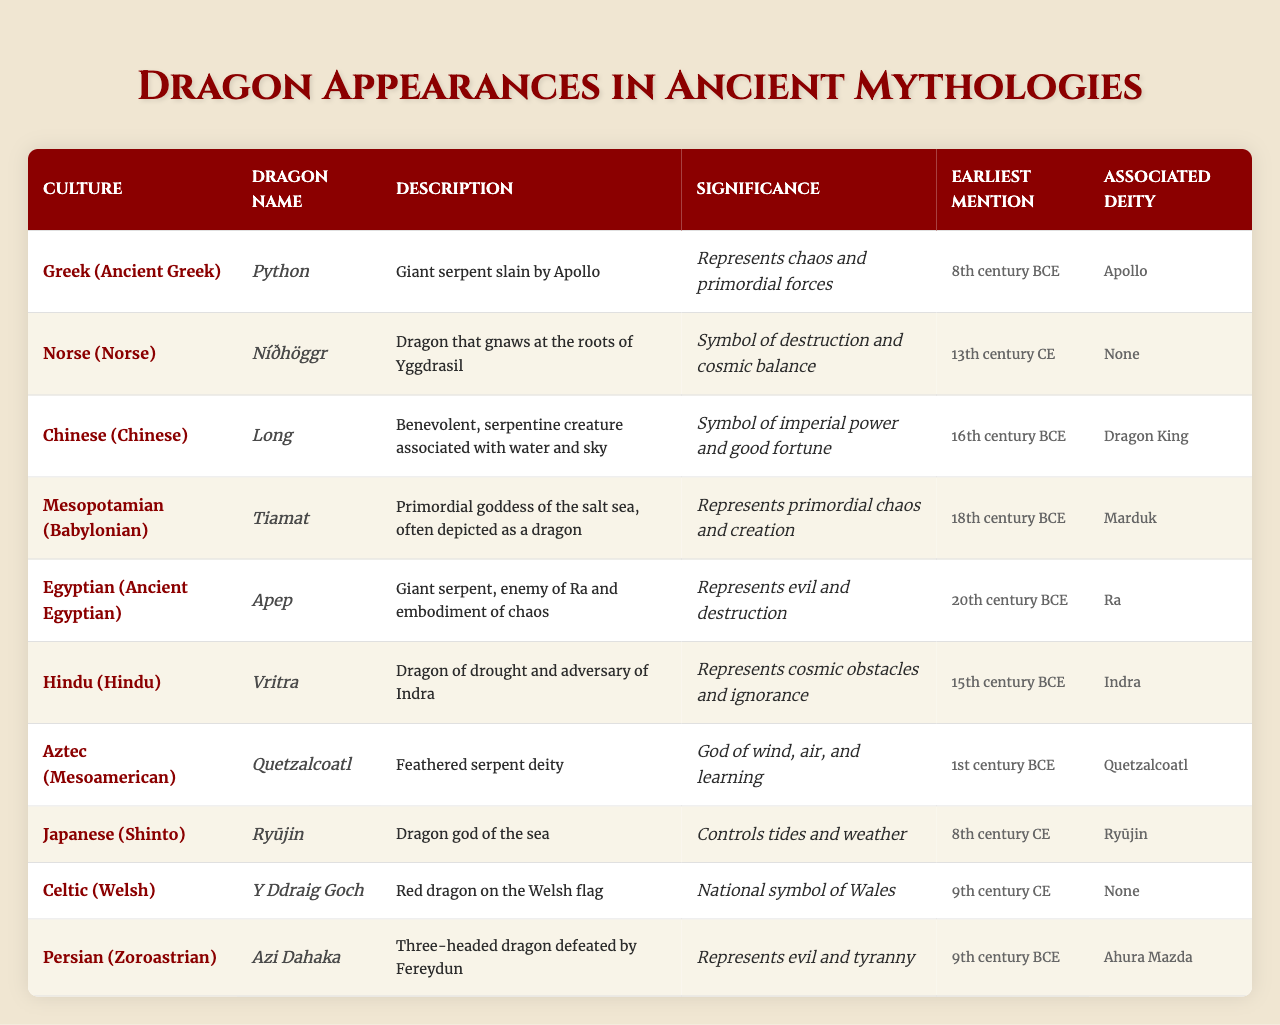What is the significance of the dragon Python in Greek mythology? According to the table, Python represents chaos and primordial forces.
Answer: Chaos and primordial forces Which culture's dragon is associated with the sea and has control over tides? The Japanese dragon Ryūjin is described as the dragon god of the sea, controlling tides and weather.
Answer: Ryūjin What is the earliest mention of the dragon Apep? The table indicates that Apep was first mentioned in the 20th century BCE.
Answer: 20th century BCE Is Níðhöggr associated with any deities? The table states that Níðhöggr does not have any associated deity.
Answer: No Which dragon represents evil and destruction and is associated with the deity Ra? The Egyptian dragon Apep represents evil and destruction and is associated with the deity Ra.
Answer: Apep Comparatively, which dragon has the earliest mention: Quetzalcoatl or Vritra? By examining the earliest mentions, Quetzalcoatl is noted in the 1st century BCE and Vritra in the 15th century BCE; thus, Quetzalcoatl has the earlier mention.
Answer: Quetzalcoatl Which culture has a dragon that embodies chaos and creation and is defeated by the deity Marduk? The Mesopotamian culture features the dragon Tiamat, who embodies chaos and creation and is defeated by Marduk.
Answer: Tiamat What is the significance of the dragon Long in Chinese mythology? Long is a symbol of imperial power and good fortune as described in the table.
Answer: Imperial power and good fortune Are there any dragons mentioned in both the Celtic and Norse cultures? The table indicates that the dragons from the Celtic and Norse cultures, Y Ddraig Goch and Níðhöggr respectively, are distinct with no overlap in names or descriptions.
Answer: No How many dragons mentioned have no associated deity? A quick review of the table shows that both Níðhöggr and Y Ddraig Goch are listed as having no associated deity, totaling two.
Answer: Two 